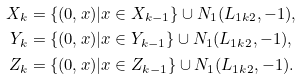Convert formula to latex. <formula><loc_0><loc_0><loc_500><loc_500>X _ { k } & = \{ ( 0 , x ) | x \in X _ { k - 1 } \} \cup N _ { 1 } ( L _ { 1 k 2 } , - 1 ) , \\ Y _ { k } & = \{ ( 0 , x ) | x \in Y _ { k - 1 } \} \cup N _ { 1 } ( L _ { 1 k 2 } , - 1 ) , \\ Z _ { k } & = \{ ( 0 , x ) | x \in Z _ { k - 1 } \} \cup N _ { 1 } ( L _ { 1 k 2 } , - 1 ) .</formula> 